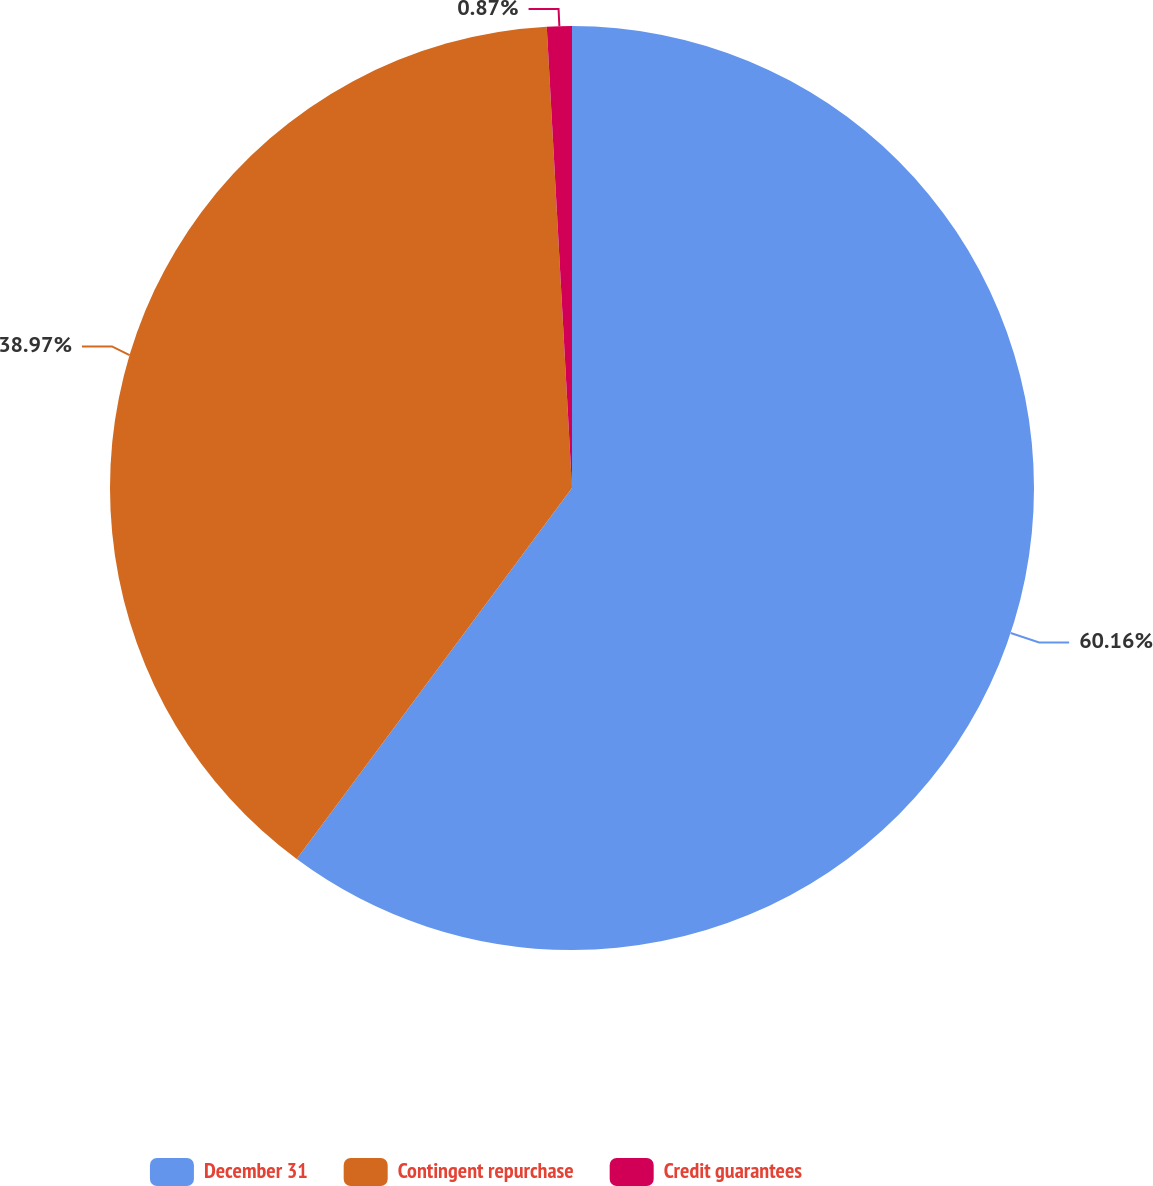Convert chart. <chart><loc_0><loc_0><loc_500><loc_500><pie_chart><fcel>December 31<fcel>Contingent repurchase<fcel>Credit guarantees<nl><fcel>60.16%<fcel>38.97%<fcel>0.87%<nl></chart> 